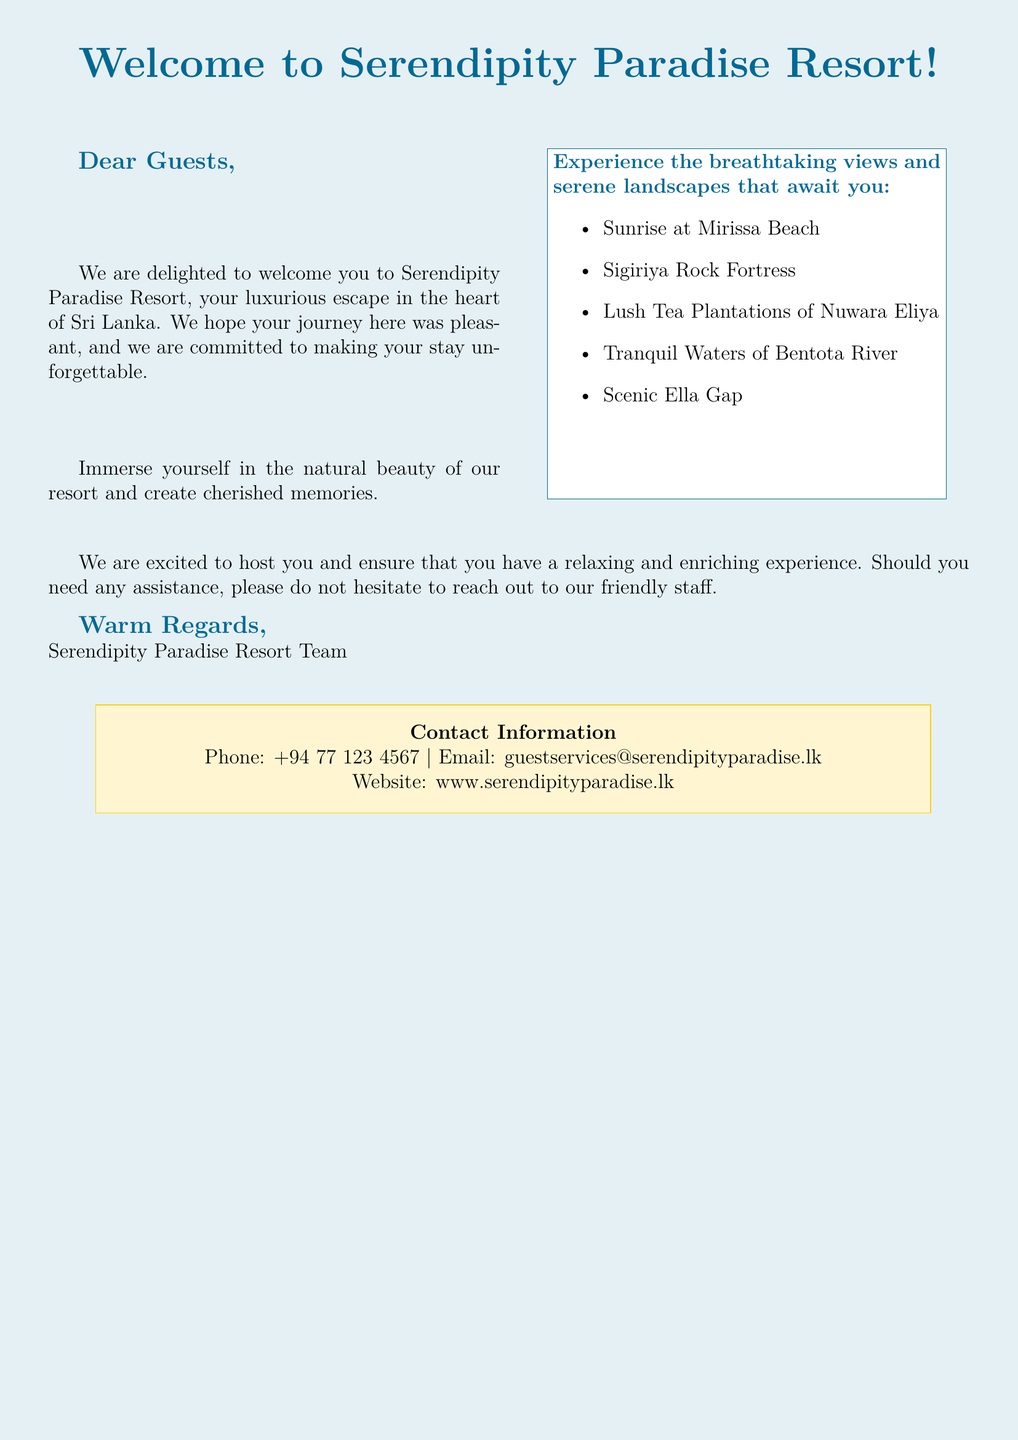What is the name of the resort? The name of the resort is mentioned at the top of the greeting card.
Answer: Serendipity Paradise Resort How many scenic views are listed? The document includes a list of scenic views available at the resort.
Answer: Five What is one of the scenic views mentioned? The document provides examples of scenic views, and we need to identify one from the provided list.
Answer: Sunrise at Mirissa Beach What is the email address for guest services? The document includes contact information, specifically the email address for guest services.
Answer: guestservices@serendipityparadise.lk Who is the signatory at the end of the card? The document states the team that is welcoming the guests at the end of the card.
Answer: Serendipity Paradise Resort Team What color is used for the background? The document describes the page color of the greeting card.
Answer: Seablue What can guests create during their stay? The text mentions what guests can do and what they will remember about their time at the resort.
Answer: Cherished memories What type of experience does the resort promise? The document promises a specific type of experience for the guests during their stay.
Answer: Relaxing and enriching experience 